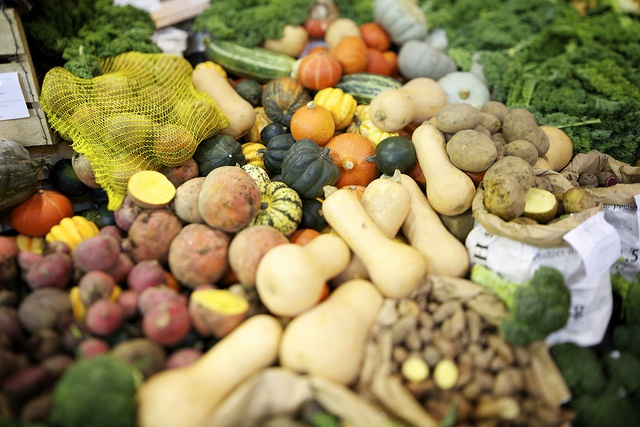Describe the objects in this image and their specific colors. I can see apple in black, olive, khaki, and gold tones, broccoli in black, darkgreen, and olive tones, broccoli in black, darkgreen, and olive tones, broccoli in black, darkgreen, and olive tones, and broccoli in black and darkgreen tones in this image. 